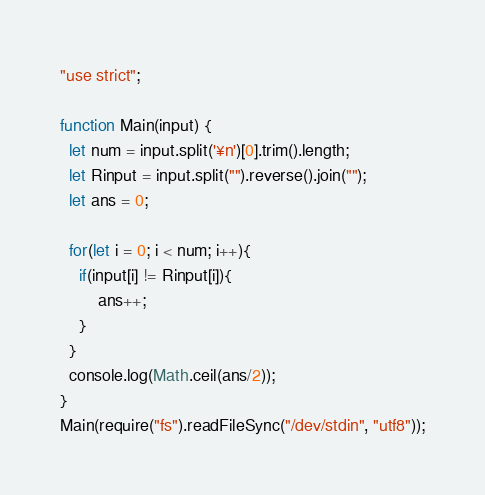<code> <loc_0><loc_0><loc_500><loc_500><_JavaScript_>"use strict";

function Main(input) {
  let num = input.split('¥n')[0].trim().length;
  let Rinput = input.split("").reverse().join("");
  let ans = 0;

  for(let i = 0; i < num; i++){
  	if(input[i] != Rinput[i]){
    	ans++;
    }
  }
  console.log(Math.ceil(ans/2));
}
Main(require("fs").readFileSync("/dev/stdin", "utf8"));
</code> 